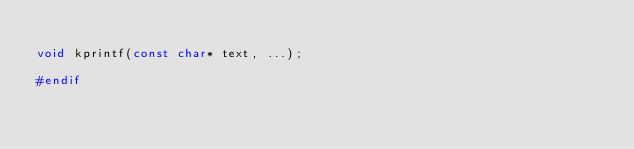<code> <loc_0><loc_0><loc_500><loc_500><_C_>
void kprintf(const char* text, ...);

#endif
</code> 